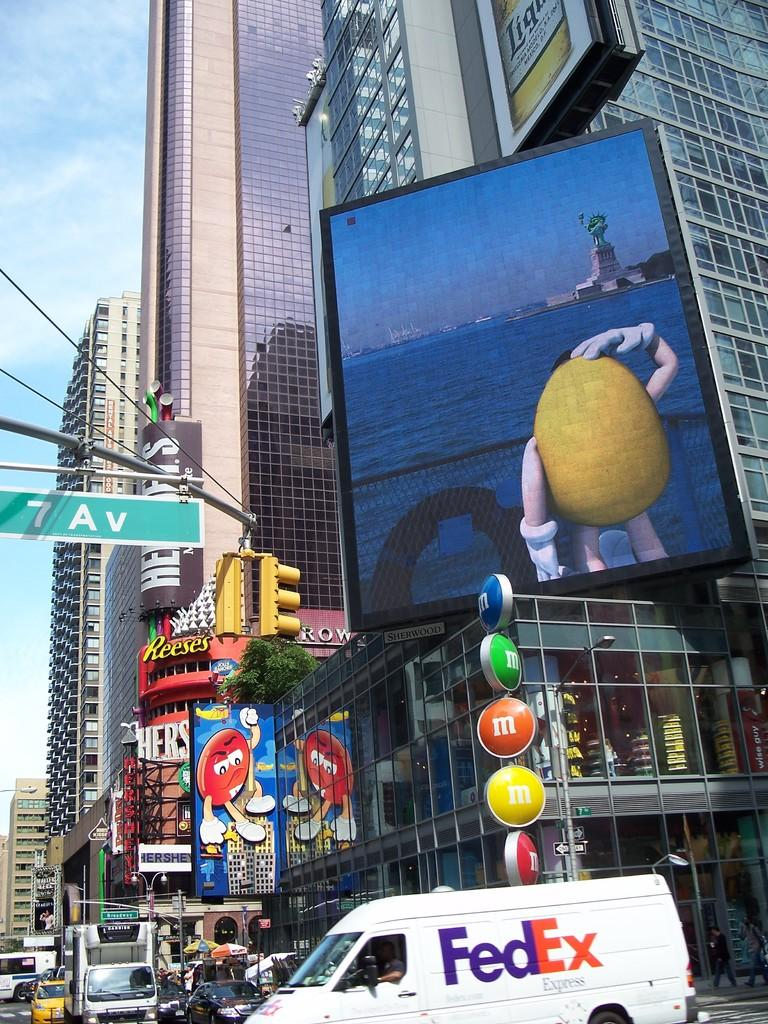<image>
Present a compact description of the photo's key features. A busy intersection that has a white fed ex van in the bottom of the image. 